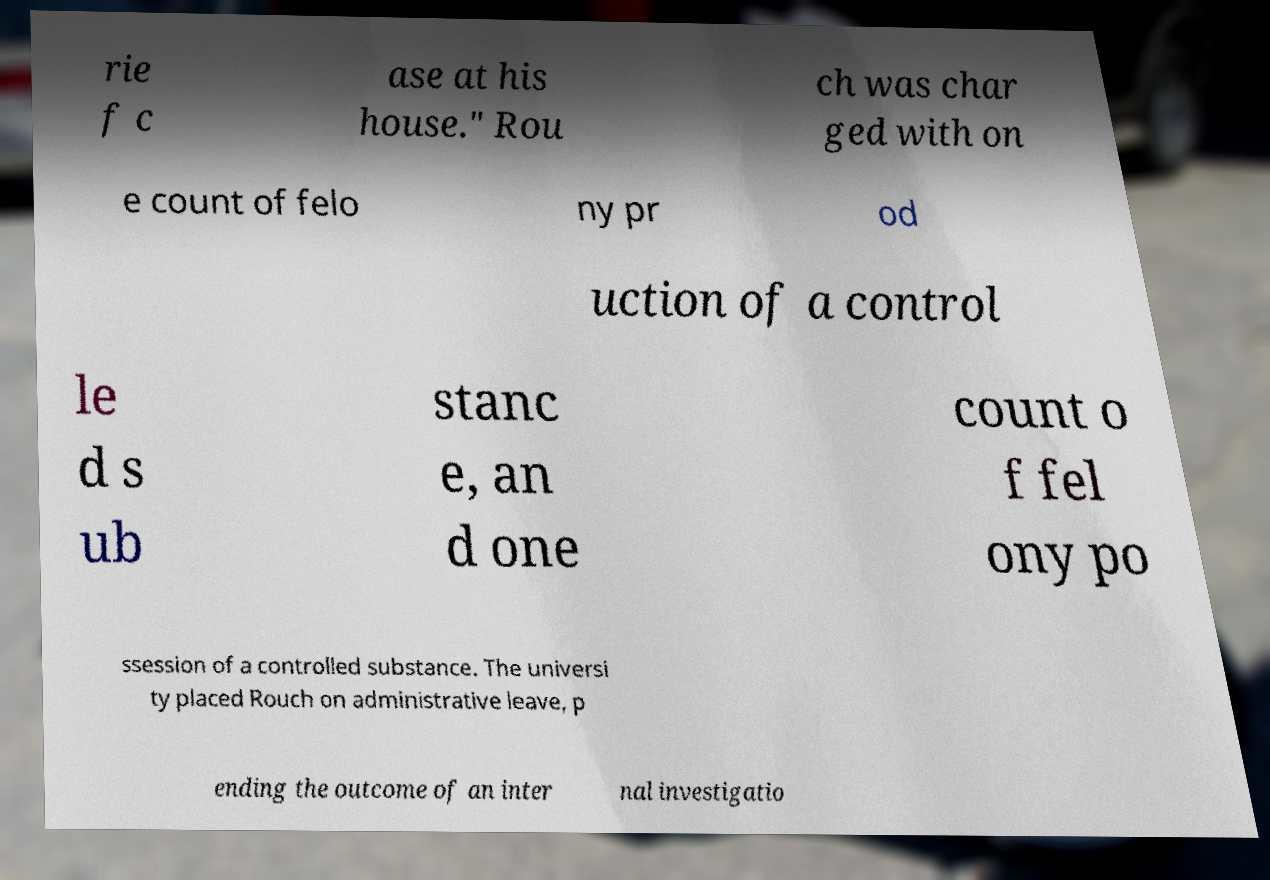There's text embedded in this image that I need extracted. Can you transcribe it verbatim? rie f c ase at his house." Rou ch was char ged with on e count of felo ny pr od uction of a control le d s ub stanc e, an d one count o f fel ony po ssession of a controlled substance. The universi ty placed Rouch on administrative leave, p ending the outcome of an inter nal investigatio 